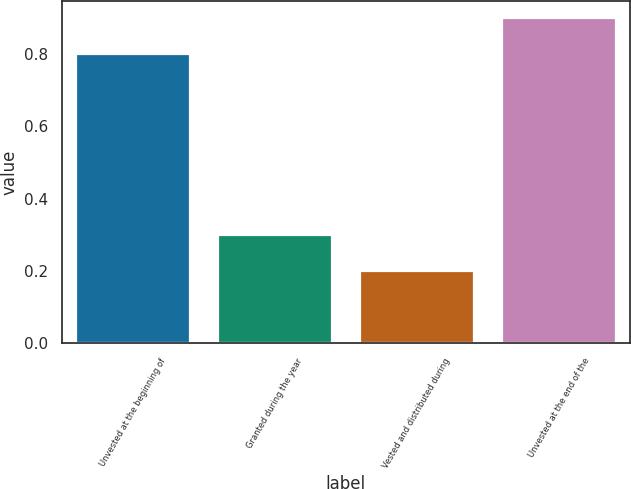Convert chart. <chart><loc_0><loc_0><loc_500><loc_500><bar_chart><fcel>Unvested at the beginning of<fcel>Granted during the year<fcel>Vested and distributed during<fcel>Unvested at the end of the<nl><fcel>0.8<fcel>0.3<fcel>0.2<fcel>0.9<nl></chart> 